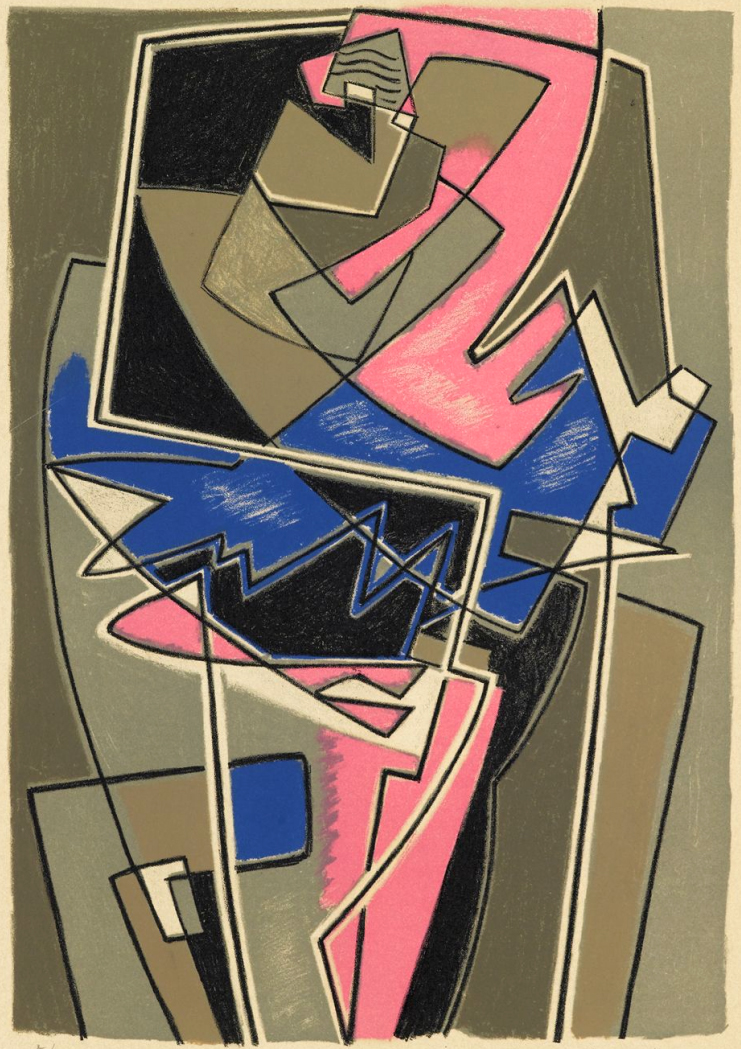What stories could be imagined from this abstract piece? A myriad of stories could be imagined from this abstract piece. Perhaps it's a visual representation of a bustling futuristic city where technology and nature coexist within geometric harmony. Or it might illustrate the chaotic thoughts of a brilliant inventor, where each shape represents a different idea or invention concept converging into a singular moment of epiphany. It could also be the map of an uncharted realm within a video game, where each color represents a different terrain type, and each shape is a landmark waiting to be explored. Can you craft a very short narrative based on this artwork? In a world where imagination shapes reality, a group of explorers stumbles upon a portal, this very artwork. Stepping through, they find themselves in a dimension where vibrant colors and sharp forms define the landscape. Their quest? To navigate the intertwining paths of this geometric labyrinth, seeking the Heart of Creativity at its center, each step transforming both them and the world around them. What could the geometric shapes represent in a personal journey? In a personal journey, the geometric shapes could represent various stages and aspects of personal growth and experiences. Each shape might symbolize a milestone, challenge, or moment of clarity. The intersections and overlaps could represent the complex interconnections and influences of different life events, showing how one experience can impact another. The vibrant hues could symbolize moments of joy, passion, and creativity, whereas the muted colors could represent periods of reflection, rest, or even struggle. Overall, the composition could be a visual metaphor for the non-linear, multifaceted nature of personal development and self-discovery. If this piece could come to life, what kind of world would it create? If this piece could come to life, it would create a world of vibrant, ever-shifting geometries where the boundaries between art and reality blur. In this world, nothing is static; the terrain undulates with angular forms that constantly reconfigure themselves, creating a labyrinthine landscape of color and shape. Buildings might rise and fall like waves, composed of semi-transparent planes through which the sky’s hues transform continuously from soft pastels to vivid neons. The inhabitants of this realm, geometric entities themselves, would live in a harmony of structured chaos, embracing the beauty in variability and finding order in the abstract patterns that define their existence. Can you explain how this artwork might inspire someone in their own creative work? This artwork, with its bold use of geometrical abstraction and dynamic hues, might inspire someone to break free from conventional forms and think outside the box. It can encourage an artist to experiment with layering and intersecting shapes to build depth and complexity in their own work. The lively contrast of colors might inspire a fashion designer to play with unexpected color palettes, or a writer to craft a narrative that intertwines diverse storylines into a cohesive whole. Overall, the piece stands as a testament to the power of abstraction to express complex ideas and emotions, motivating others to explore and push the boundaries of their creative fields. 